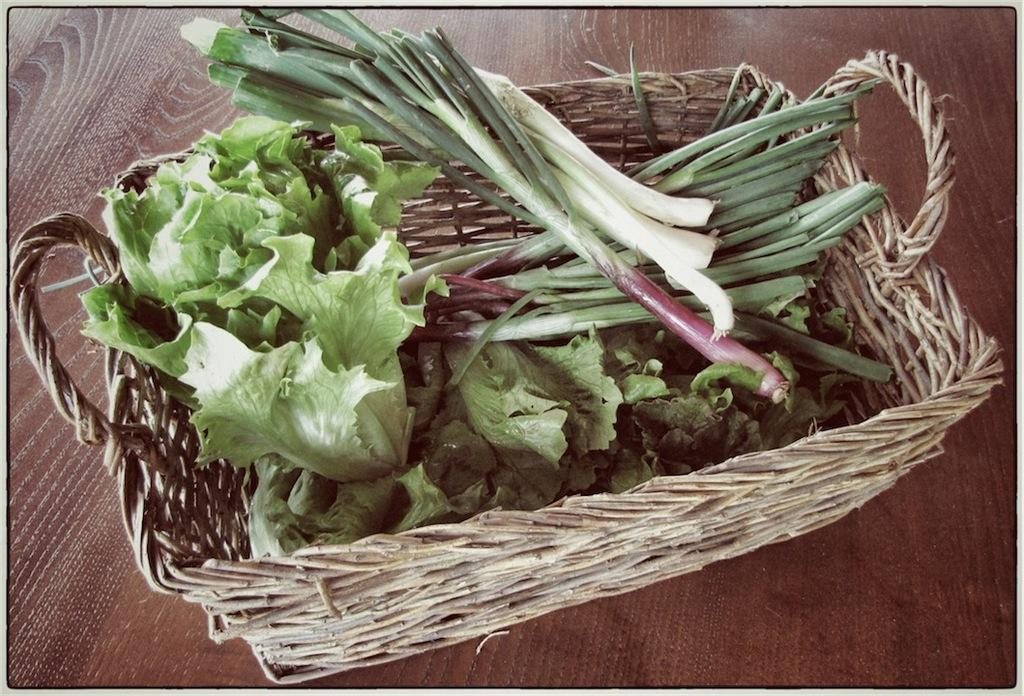What type of food items are in the basket in the image? There are vegetables in a basket in the image. Can you describe the wooden object in the background of the image? Unfortunately, the facts provided do not give any details about the wooden object in the background. What rhythm is the vegetable basket following in the image? There is no rhythm associated with the vegetable basket in the image; it is stationary in the basket. 